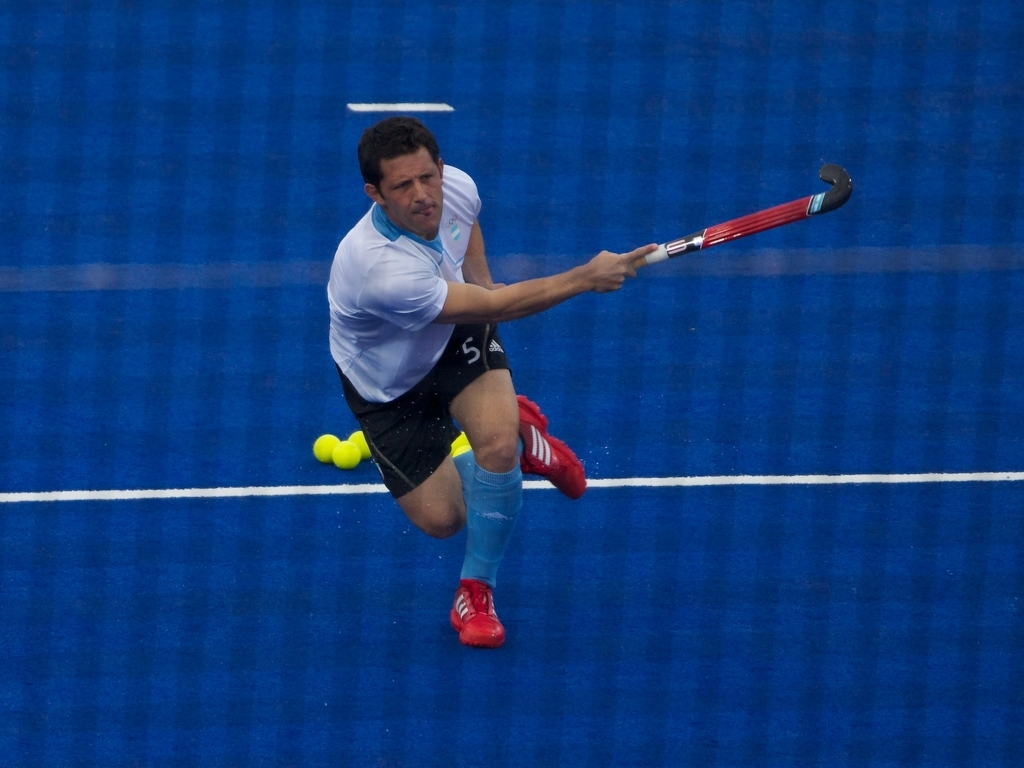Are there any quality issues with this image? The image is generally of good quality but appears slightly blurred, suggesting motion or action captured at a high speed. The focus and lighting are adequate, making the main subject, a field hockey player in mid-motion, visibly clear. No significant pixelation or compression artifacts are present. 